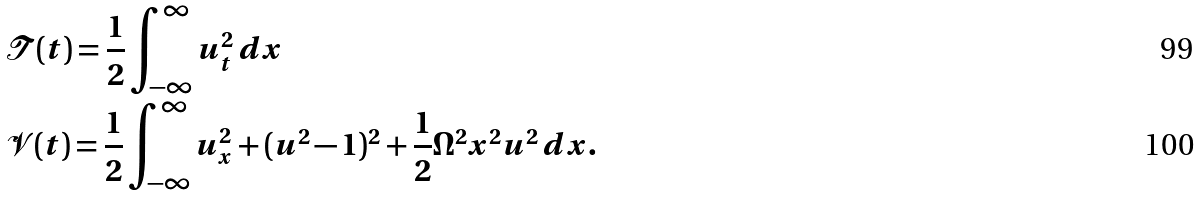<formula> <loc_0><loc_0><loc_500><loc_500>& \mathcal { T } ( t ) = \frac { 1 } { 2 } \int _ { - \infty } ^ { \infty } u _ { t } ^ { 2 } \, d x \\ & \mathcal { V } ( t ) = \frac { 1 } { 2 } \int _ { - \infty } ^ { \infty } u _ { x } ^ { 2 } + ( u ^ { 2 } - 1 ) ^ { 2 } + \frac { 1 } { 2 } \Omega ^ { 2 } x ^ { 2 } u ^ { 2 } \, d x .</formula> 